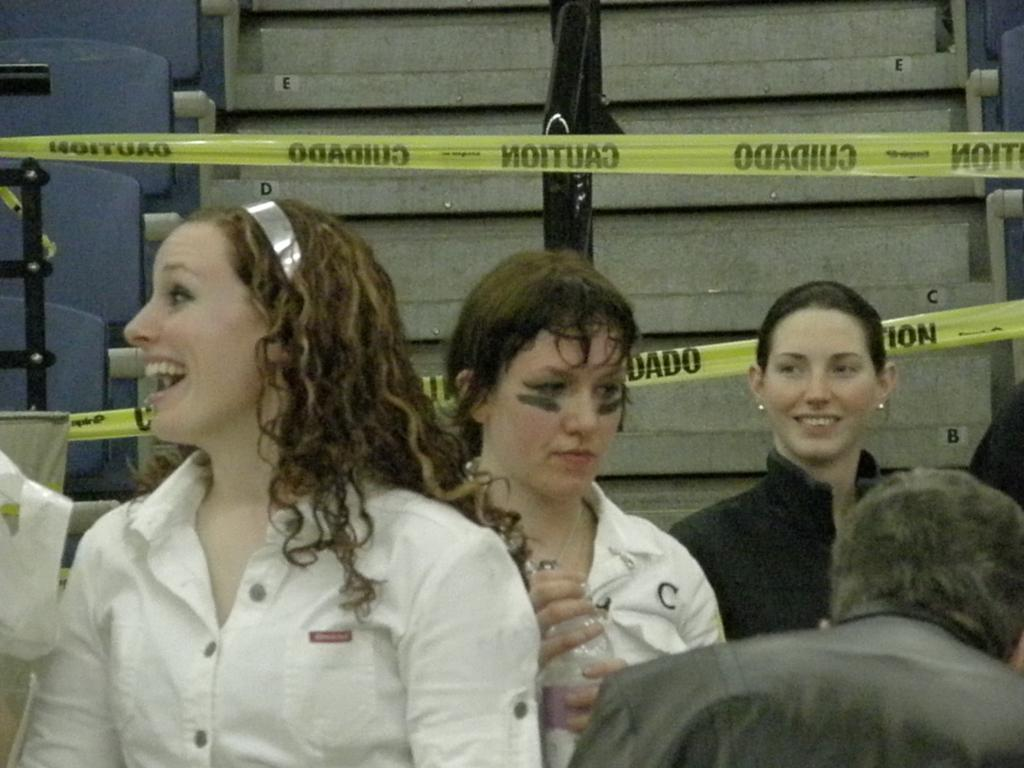What is the main subject of the image? The main subject of the image is a group of people. Can you describe one person in the group? There is a woman in the image, and she is smiling. What can be seen in the background of the image? There are metal rods and chairs in the background of the image. What type of twist can be seen in the image? There is no twist present in the image. What kind of voyage are the people in the image embarking on? There is no indication of a voyage in the image; it simply shows a group of people and a woman smiling. 